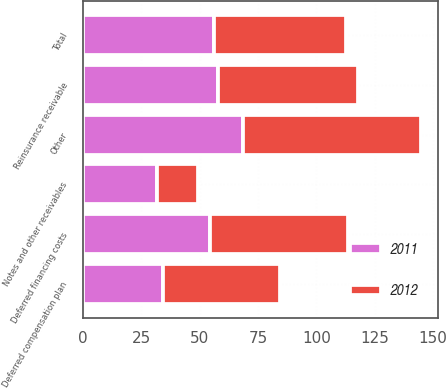<chart> <loc_0><loc_0><loc_500><loc_500><stacked_bar_chart><ecel><fcel>Deferred financing costs<fcel>Deferred compensation plan<fcel>Notes and other receivables<fcel>Reinsurance receivable<fcel>Other<fcel>Total<nl><fcel>2012<fcel>58.8<fcel>49.9<fcel>17.9<fcel>59.7<fcel>76.1<fcel>56.3<nl><fcel>2011<fcel>54.6<fcel>34.5<fcel>31.6<fcel>58<fcel>68.6<fcel>56.3<nl></chart> 